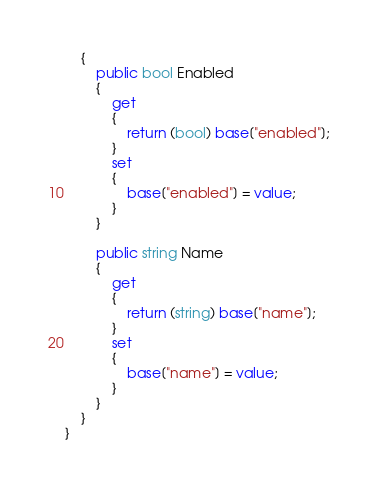<code> <loc_0><loc_0><loc_500><loc_500><_C#_>    {
        public bool Enabled
        {
            get
            {
                return (bool) base["enabled"];
            }
            set
            {
                base["enabled"] = value;
            }
        }

        public string Name
        {
            get
            {
                return (string) base["name"];
            }
            set
            {
                base["name"] = value;
            }
        }
    }
}

</code> 